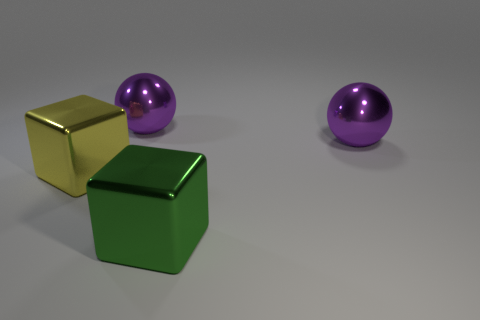Add 3 large purple things. How many objects exist? 7 Add 3 big green things. How many big green things exist? 4 Subtract 0 gray spheres. How many objects are left? 4 Subtract all yellow shiny things. Subtract all green shiny cubes. How many objects are left? 2 Add 3 big yellow objects. How many big yellow objects are left? 4 